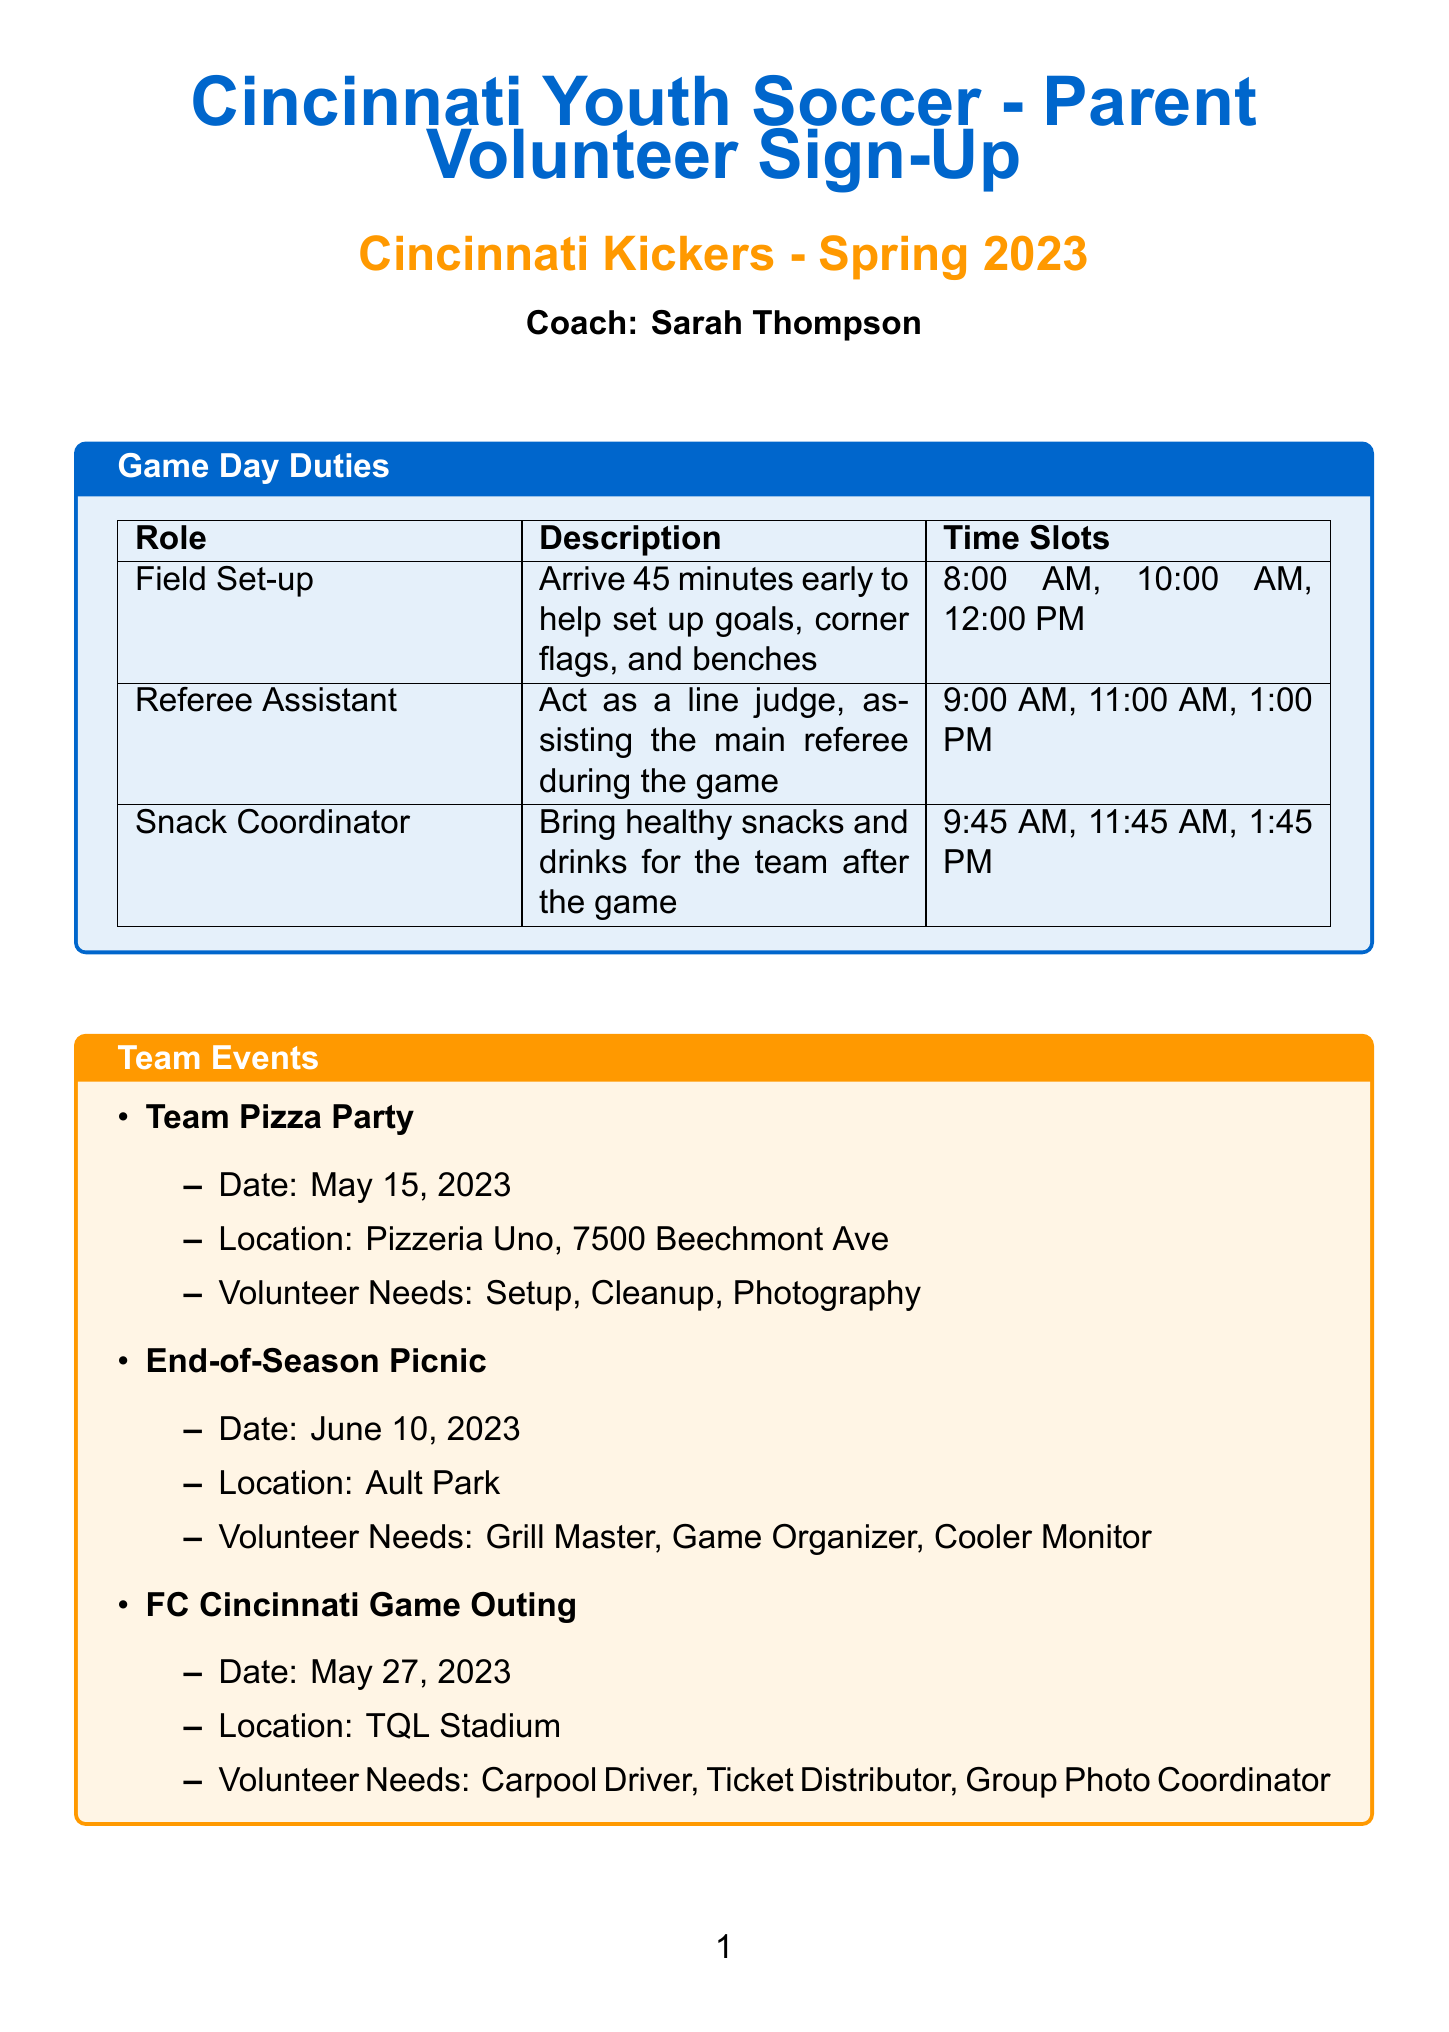What is the title of the form? The title of the form is stated prominently at the beginning, indicating its purpose and organization.
Answer: Cincinnati Youth Soccer - Parent Volunteer Sign-Up What is the name of the team? The document specifies the team name under the title to clearly identify the group involved.
Answer: Cincinnati Kickers Who is the coach? The coach's name is mentioned in the document, serving as a point of contact for parents.
Answer: Coach Sarah Thompson What date is the Team Pizza Party scheduled for? The date is listed under the Team Events section, providing information about an upcoming social event.
Answer: May 15, 2023 What role involves setting up goals and flags? The document includes a specific role description which specifies responsibilities for game day tasks.
Answer: Field Set-up How many volunteer needs are listed for the End-of-Season Picnic? The number of volunteer needs can be determined by counting the listed roles in the event details.
Answer: 3 What location is mentioned for the FC Cincinnati Game Outing? The document states the location clearly for event logistics to assist parents and volunteers.
Answer: TQL Stadium Which section lists the roles needed on game days? The structure of the document organizes information into sections, with specific roles described for clarity.
Answer: Game Day Duties How can parents contact the coach? The contact information section provides details for communication with the coach, ensuring parents can reach out easily.
Answer: coach.sarah@cincinnatikickers.com 